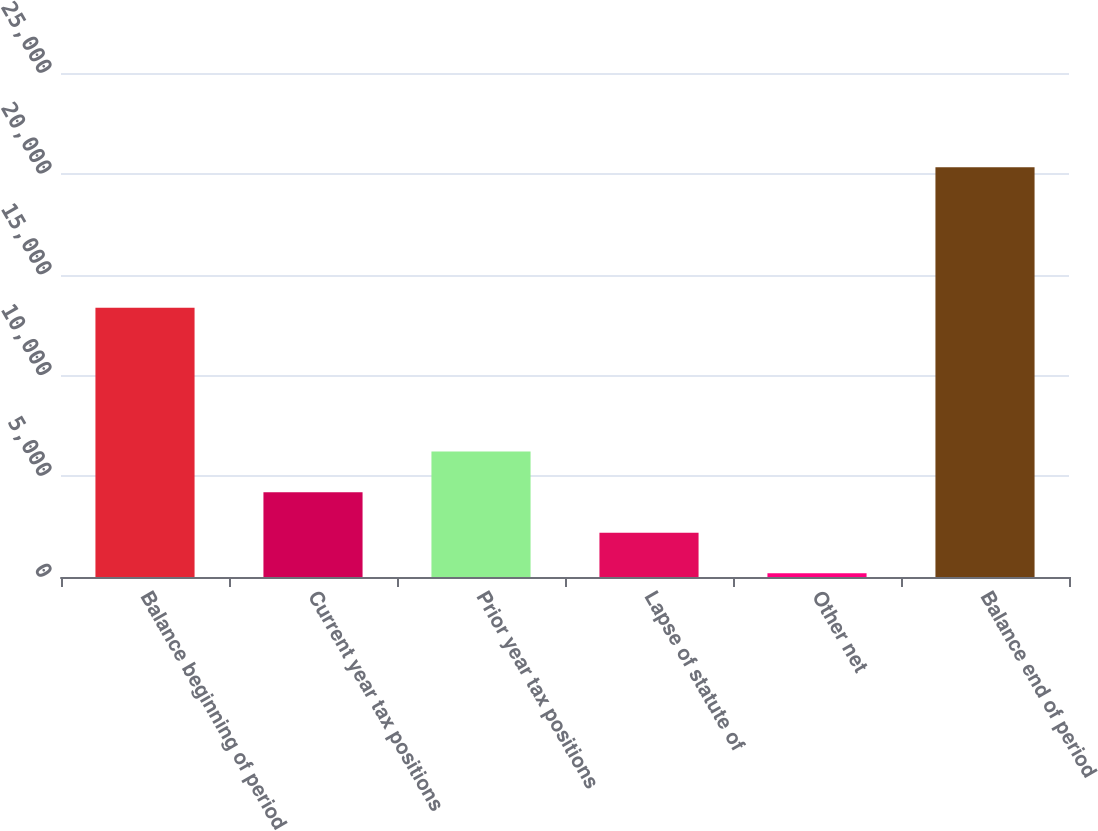Convert chart. <chart><loc_0><loc_0><loc_500><loc_500><bar_chart><fcel>Balance beginning of period<fcel>Current year tax positions<fcel>Prior year tax positions<fcel>Lapse of statute of<fcel>Other net<fcel>Balance end of period<nl><fcel>13352<fcel>4209.6<fcel>6224.4<fcel>2194.8<fcel>180<fcel>20328<nl></chart> 